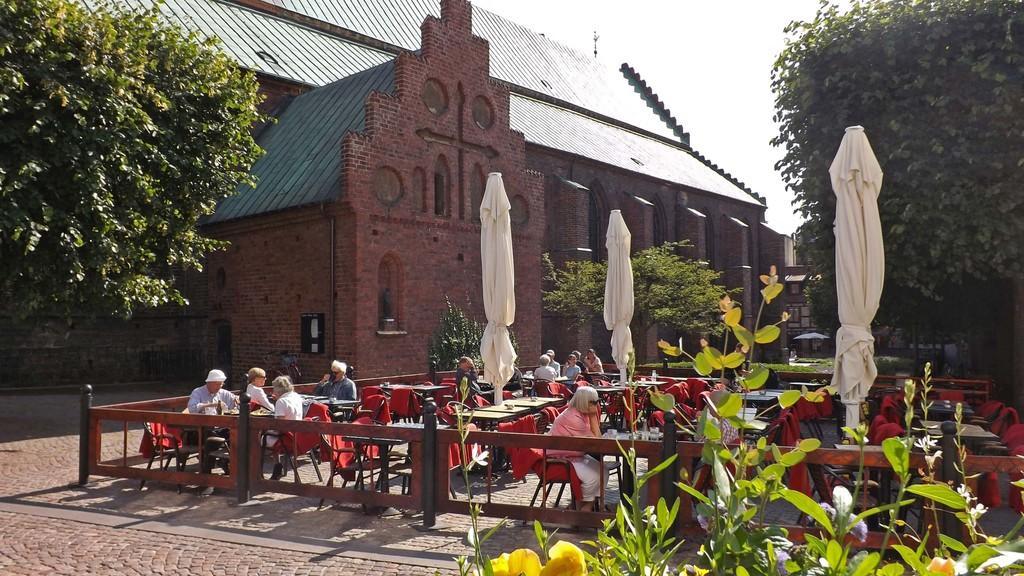How would you summarize this image in a sentence or two? In this image I can see the group of people sitting on the chairs and there are tables in-front of these people. I can also see many tables and chairs to the side. And there is a railing to the side. In the background I can see the building. To the side of the building I can see many trees. I can also see the sky in the back. 